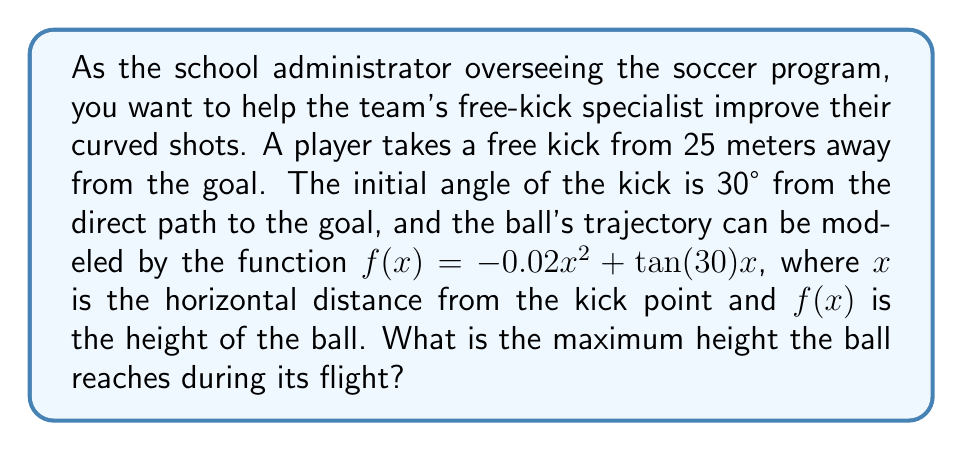What is the answer to this math problem? To find the maximum height of the ball's trajectory, we need to follow these steps:

1) The function given is $f(x) = -0.02x^2 + \tan(30°)x$

2) First, let's simplify $\tan(30°)$:
   $\tan(30°) = \frac{1}{\sqrt{3}} \approx 0.577$

3) Now our function is: $f(x) = -0.02x^2 + 0.577x$

4) To find the maximum point, we need to find where the derivative of this function equals zero:
   $f'(x) = -0.04x + 0.577$

5) Set $f'(x) = 0$ and solve for $x$:
   $-0.04x + 0.577 = 0$
   $-0.04x = -0.577$
   $x = \frac{0.577}{0.04} = 14.425$ meters

6) This $x$ value represents the horizontal distance where the ball reaches its maximum height.

7) To find the maximum height, we plug this $x$ value back into our original function:

   $f(14.425) = -0.02(14.425)^2 + 0.577(14.425)$
               $= -0.02(208.08) + 8.32$
               $= -4.16 + 8.32$
               $= 4.16$ meters

Therefore, the maximum height the ball reaches is approximately 4.16 meters.
Answer: The maximum height the ball reaches during its flight is approximately 4.16 meters. 